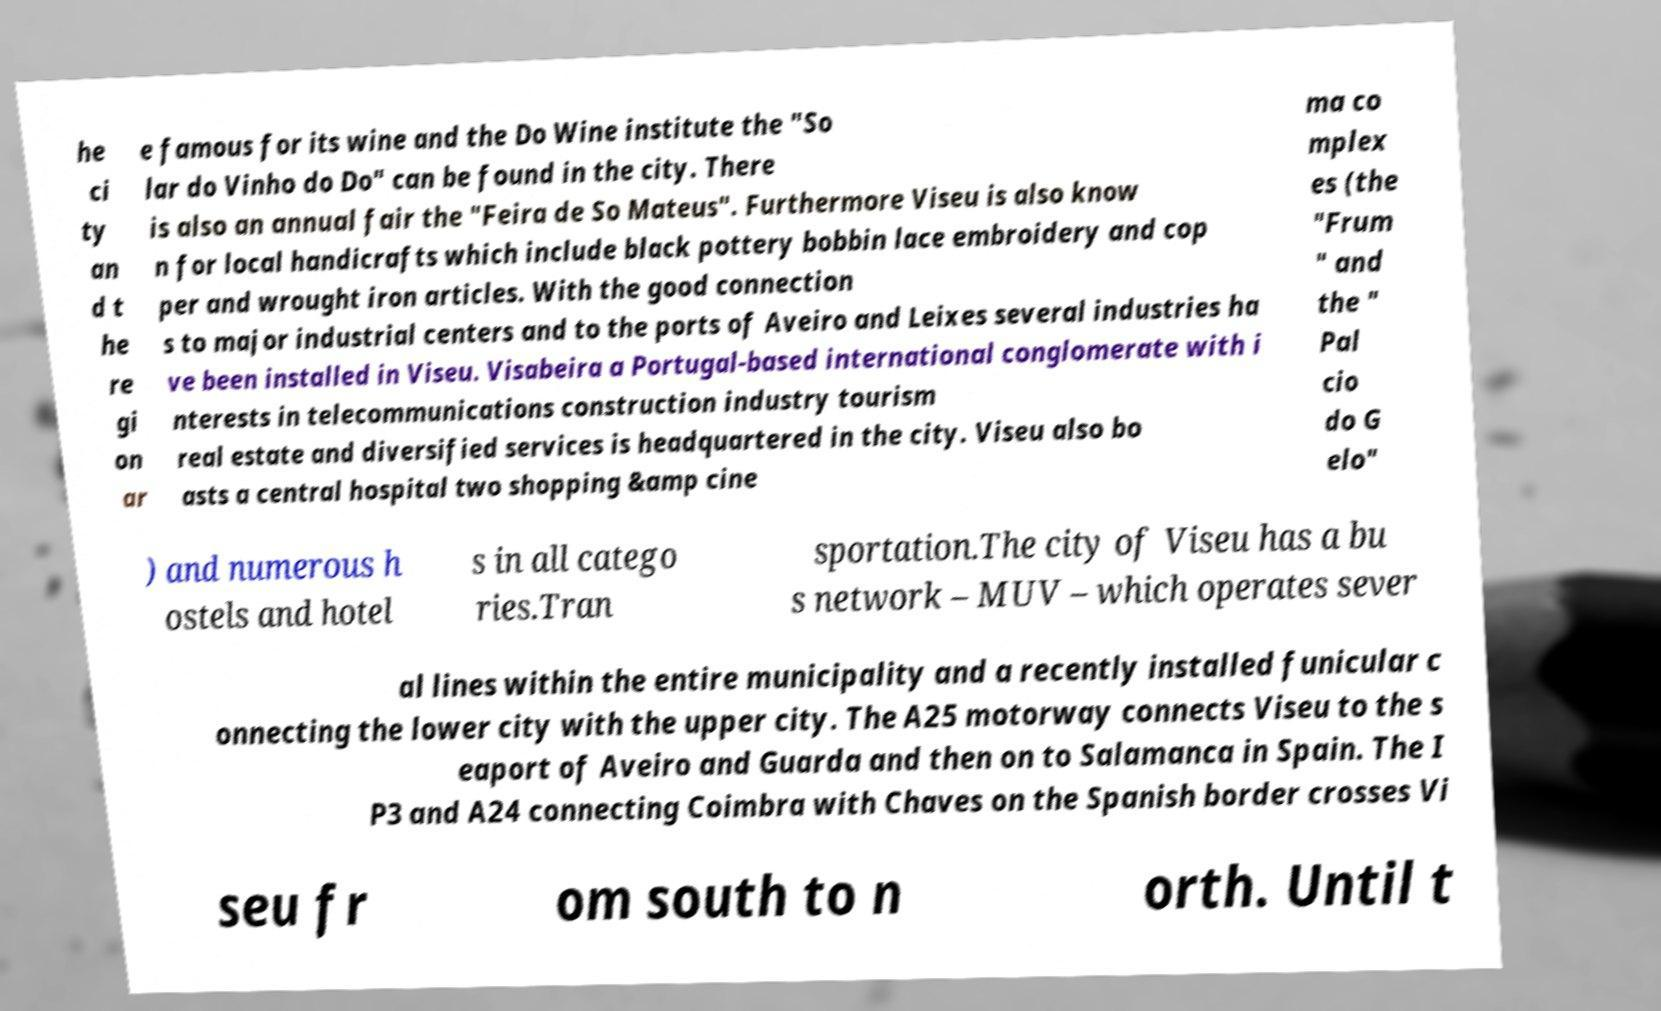Could you extract and type out the text from this image? he ci ty an d t he re gi on ar e famous for its wine and the Do Wine institute the "So lar do Vinho do Do" can be found in the city. There is also an annual fair the "Feira de So Mateus". Furthermore Viseu is also know n for local handicrafts which include black pottery bobbin lace embroidery and cop per and wrought iron articles. With the good connection s to major industrial centers and to the ports of Aveiro and Leixes several industries ha ve been installed in Viseu. Visabeira a Portugal-based international conglomerate with i nterests in telecommunications construction industry tourism real estate and diversified services is headquartered in the city. Viseu also bo asts a central hospital two shopping &amp cine ma co mplex es (the "Frum " and the " Pal cio do G elo" ) and numerous h ostels and hotel s in all catego ries.Tran sportation.The city of Viseu has a bu s network – MUV – which operates sever al lines within the entire municipality and a recently installed funicular c onnecting the lower city with the upper city. The A25 motorway connects Viseu to the s eaport of Aveiro and Guarda and then on to Salamanca in Spain. The I P3 and A24 connecting Coimbra with Chaves on the Spanish border crosses Vi seu fr om south to n orth. Until t 